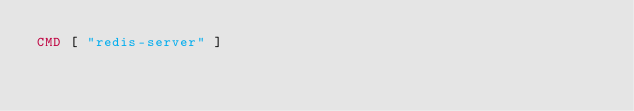Convert code to text. <code><loc_0><loc_0><loc_500><loc_500><_Dockerfile_>CMD [ "redis-server" ]
</code> 